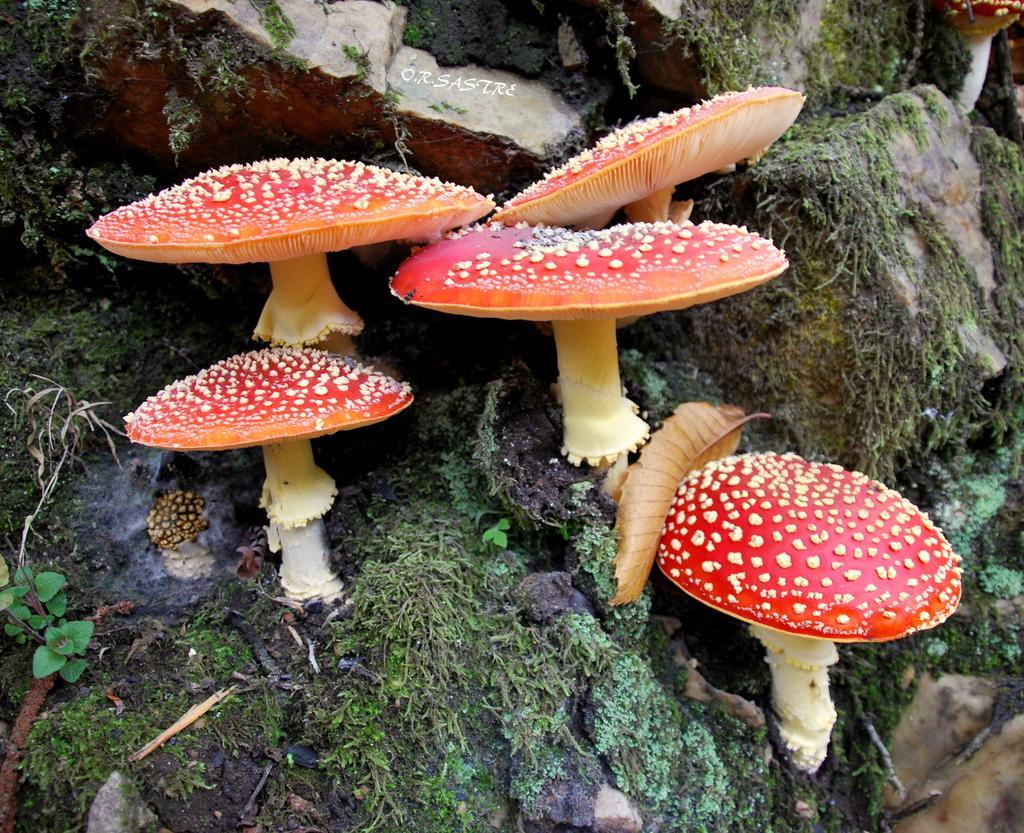How would you summarize this image in a sentence or two? In the center of the image, we can see mushrooms and at the bottom, there are rocks. 